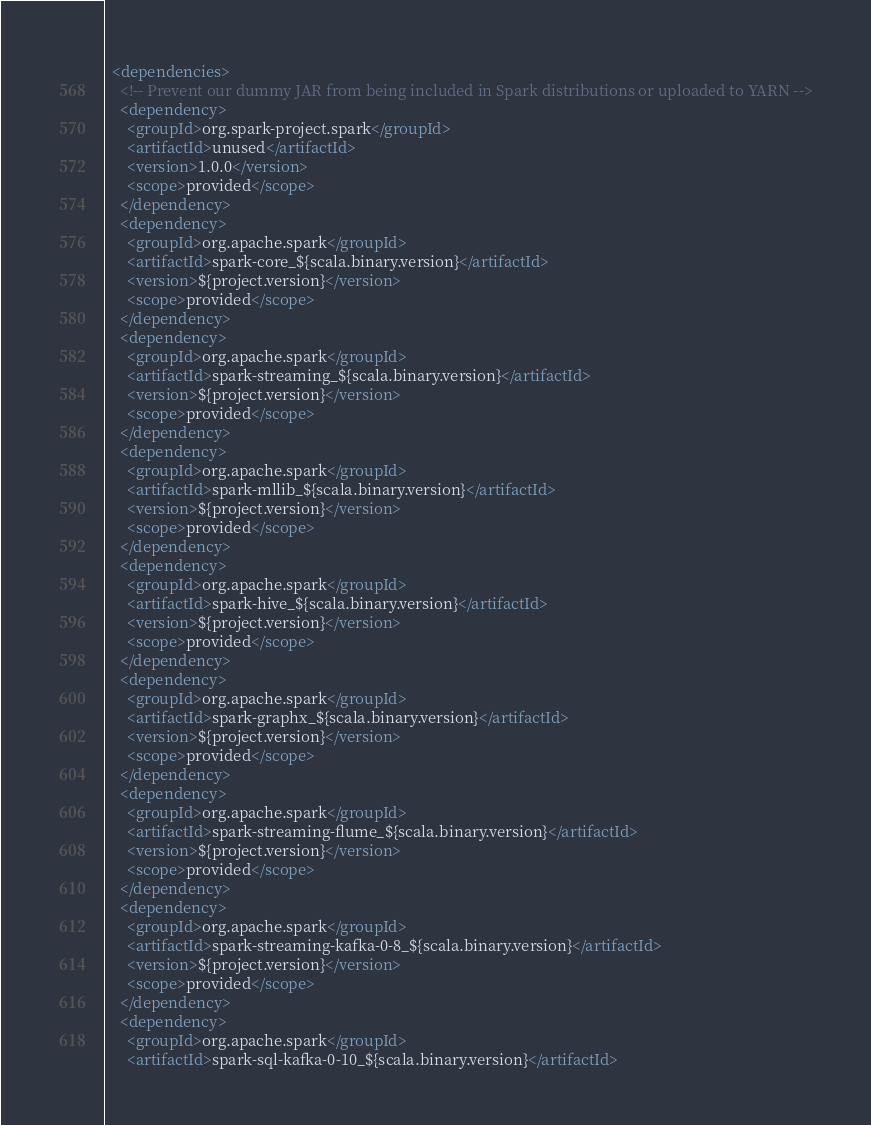<code> <loc_0><loc_0><loc_500><loc_500><_XML_>
  <dependencies>
    <!-- Prevent our dummy JAR from being included in Spark distributions or uploaded to YARN -->
    <dependency>
      <groupId>org.spark-project.spark</groupId>
      <artifactId>unused</artifactId>
      <version>1.0.0</version>
      <scope>provided</scope>
    </dependency>
    <dependency>
      <groupId>org.apache.spark</groupId>
      <artifactId>spark-core_${scala.binary.version}</artifactId>
      <version>${project.version}</version>
      <scope>provided</scope>
    </dependency>
    <dependency>
      <groupId>org.apache.spark</groupId>
      <artifactId>spark-streaming_${scala.binary.version}</artifactId>
      <version>${project.version}</version>
      <scope>provided</scope>
    </dependency>
    <dependency>
      <groupId>org.apache.spark</groupId>
      <artifactId>spark-mllib_${scala.binary.version}</artifactId>
      <version>${project.version}</version>
      <scope>provided</scope>
    </dependency>
    <dependency>
      <groupId>org.apache.spark</groupId>
      <artifactId>spark-hive_${scala.binary.version}</artifactId>
      <version>${project.version}</version>
      <scope>provided</scope>
    </dependency>
    <dependency>
      <groupId>org.apache.spark</groupId>
      <artifactId>spark-graphx_${scala.binary.version}</artifactId>
      <version>${project.version}</version>
      <scope>provided</scope>
    </dependency>
    <dependency>
      <groupId>org.apache.spark</groupId>
      <artifactId>spark-streaming-flume_${scala.binary.version}</artifactId>
      <version>${project.version}</version>
      <scope>provided</scope>
    </dependency>
    <dependency>
      <groupId>org.apache.spark</groupId>
      <artifactId>spark-streaming-kafka-0-8_${scala.binary.version}</artifactId>
      <version>${project.version}</version>
      <scope>provided</scope>
    </dependency>
    <dependency>
      <groupId>org.apache.spark</groupId>
      <artifactId>spark-sql-kafka-0-10_${scala.binary.version}</artifactId></code> 